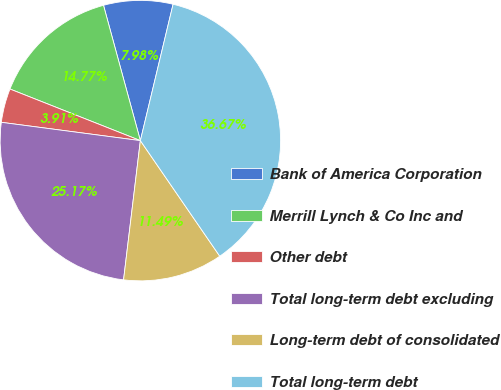Convert chart to OTSL. <chart><loc_0><loc_0><loc_500><loc_500><pie_chart><fcel>Bank of America Corporation<fcel>Merrill Lynch & Co Inc and<fcel>Other debt<fcel>Total long-term debt excluding<fcel>Long-term debt of consolidated<fcel>Total long-term debt<nl><fcel>7.98%<fcel>14.77%<fcel>3.91%<fcel>25.17%<fcel>11.49%<fcel>36.67%<nl></chart> 